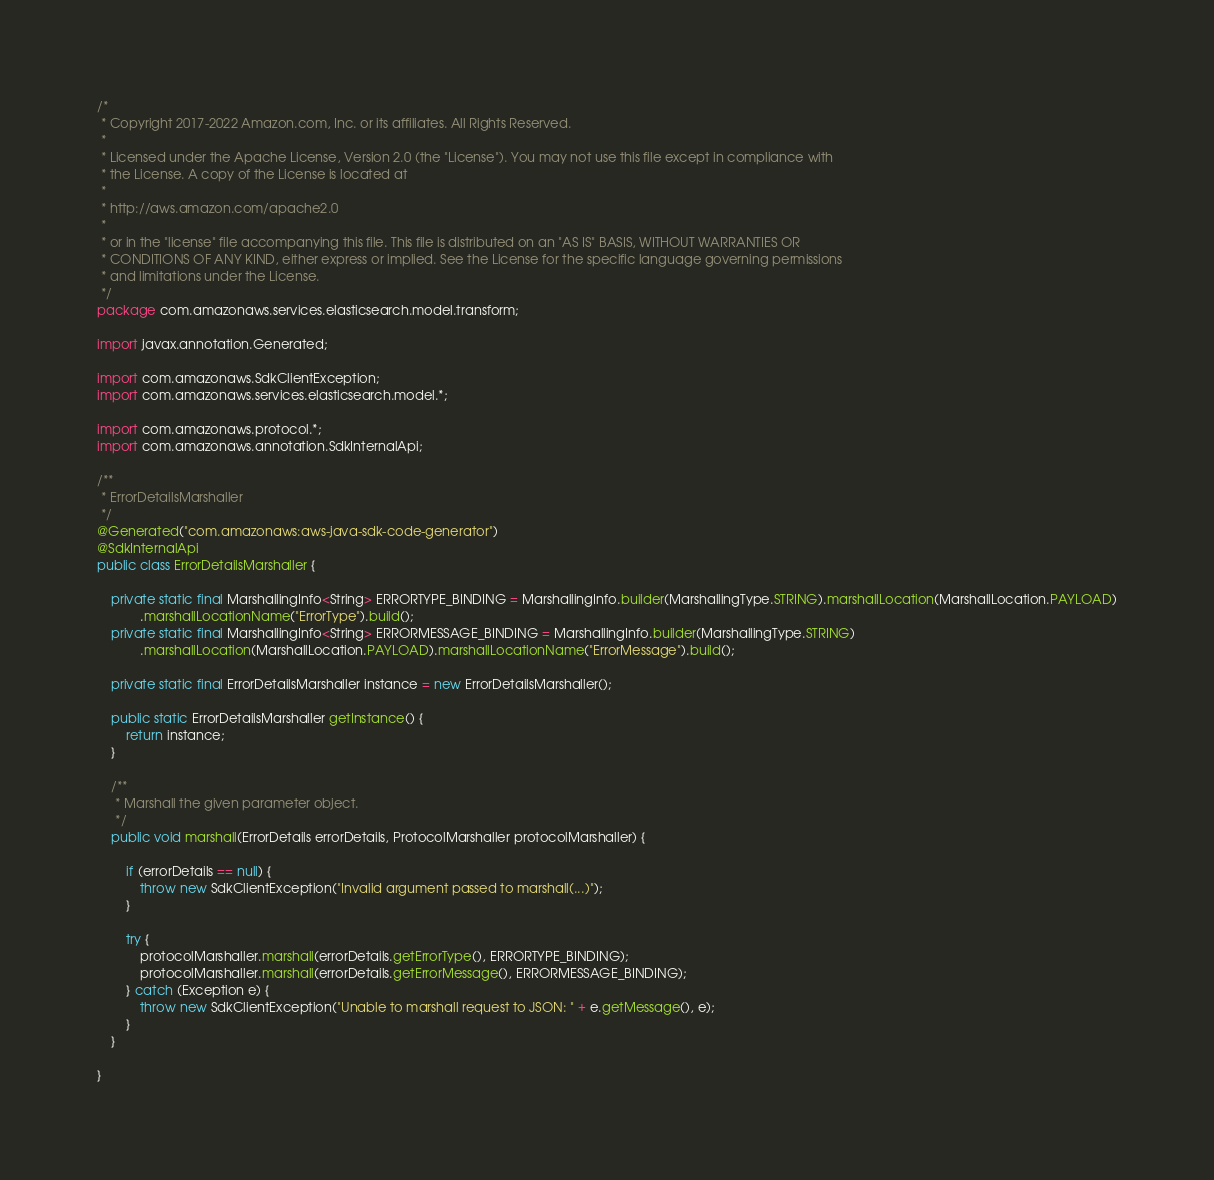<code> <loc_0><loc_0><loc_500><loc_500><_Java_>/*
 * Copyright 2017-2022 Amazon.com, Inc. or its affiliates. All Rights Reserved.
 * 
 * Licensed under the Apache License, Version 2.0 (the "License"). You may not use this file except in compliance with
 * the License. A copy of the License is located at
 * 
 * http://aws.amazon.com/apache2.0
 * 
 * or in the "license" file accompanying this file. This file is distributed on an "AS IS" BASIS, WITHOUT WARRANTIES OR
 * CONDITIONS OF ANY KIND, either express or implied. See the License for the specific language governing permissions
 * and limitations under the License.
 */
package com.amazonaws.services.elasticsearch.model.transform;

import javax.annotation.Generated;

import com.amazonaws.SdkClientException;
import com.amazonaws.services.elasticsearch.model.*;

import com.amazonaws.protocol.*;
import com.amazonaws.annotation.SdkInternalApi;

/**
 * ErrorDetailsMarshaller
 */
@Generated("com.amazonaws:aws-java-sdk-code-generator")
@SdkInternalApi
public class ErrorDetailsMarshaller {

    private static final MarshallingInfo<String> ERRORTYPE_BINDING = MarshallingInfo.builder(MarshallingType.STRING).marshallLocation(MarshallLocation.PAYLOAD)
            .marshallLocationName("ErrorType").build();
    private static final MarshallingInfo<String> ERRORMESSAGE_BINDING = MarshallingInfo.builder(MarshallingType.STRING)
            .marshallLocation(MarshallLocation.PAYLOAD).marshallLocationName("ErrorMessage").build();

    private static final ErrorDetailsMarshaller instance = new ErrorDetailsMarshaller();

    public static ErrorDetailsMarshaller getInstance() {
        return instance;
    }

    /**
     * Marshall the given parameter object.
     */
    public void marshall(ErrorDetails errorDetails, ProtocolMarshaller protocolMarshaller) {

        if (errorDetails == null) {
            throw new SdkClientException("Invalid argument passed to marshall(...)");
        }

        try {
            protocolMarshaller.marshall(errorDetails.getErrorType(), ERRORTYPE_BINDING);
            protocolMarshaller.marshall(errorDetails.getErrorMessage(), ERRORMESSAGE_BINDING);
        } catch (Exception e) {
            throw new SdkClientException("Unable to marshall request to JSON: " + e.getMessage(), e);
        }
    }

}
</code> 